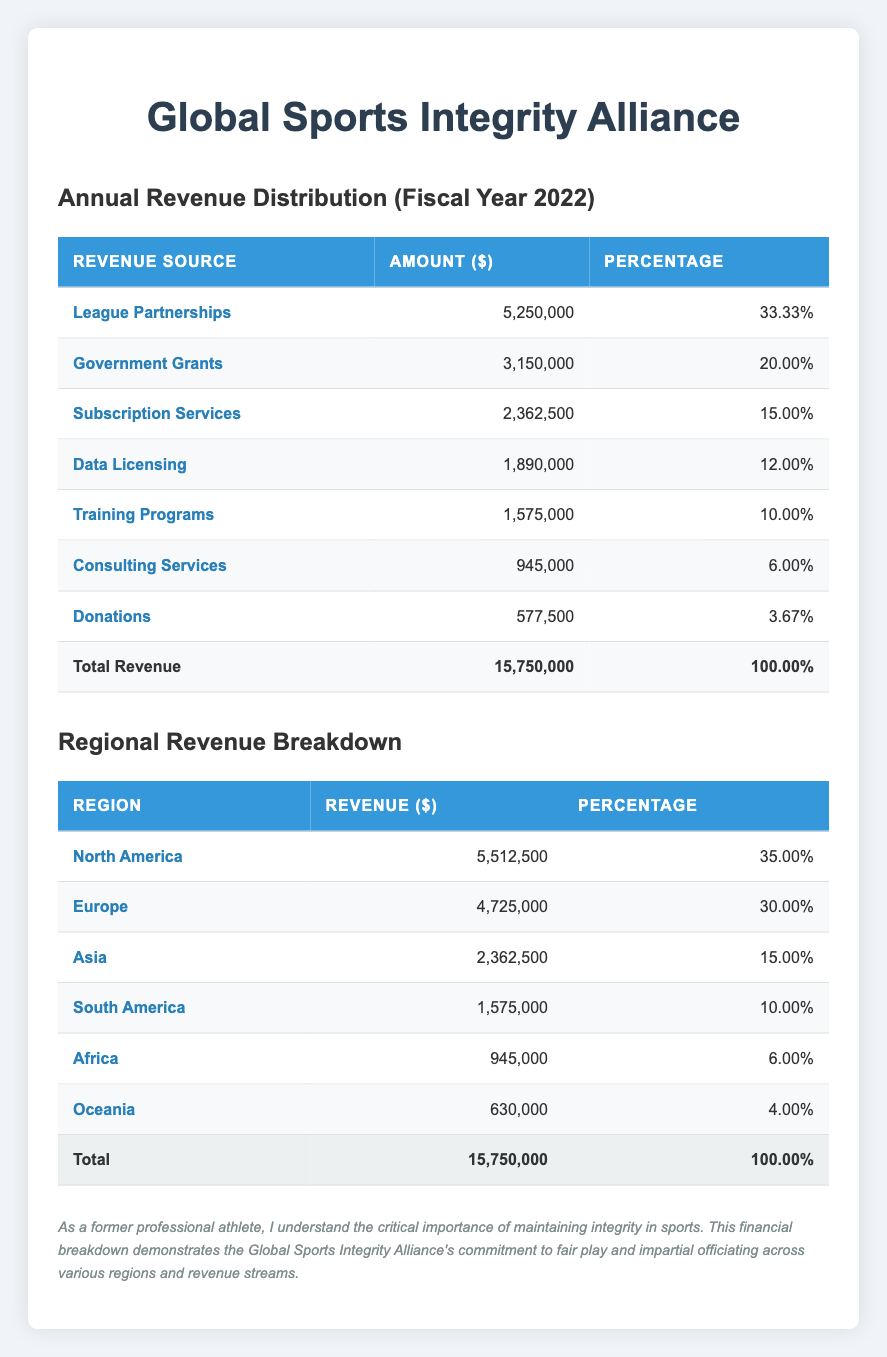What is the total revenue reported for the fiscal year 2022? The total revenue is indicated clearly at the bottom of the first table, which shows "Total Revenue" as 15,750,000.
Answer: 15,750,000 Which revenue source contributed the most to the overall revenue? Looking at the first table, the "League Partnerships" row has the highest amount listed at 5,250,000.
Answer: League Partnerships What percentage of the total revenue comes from Government Grants? From the first table, under the "Government Grants" row, the amount is 3,150,000 and the percentage is listed as 20.00%.
Answer: 20.00% Which region has the lowest revenue contribution? Examining the regional breakdown table, "Oceania" has the lowest revenue at 630,000, as indicated in the corresponding row.
Answer: Oceania If we add up the revenue from North America and Europe, how much total revenue is generated from these two regions? The amount for North America is 5,512,500 and for Europe is 4,725,000. Adding these gives 5,512,500 + 4,725,000 = 10,237,500.
Answer: 10,237,500 Is the revenue from Subscription Services greater than that from Consulting Services? The "Subscription Services" revenue is 2,362,500, while "Consulting Services" revenue is 945,000. Since 2,362,500 > 945,000, the statement is true.
Answer: Yes What is the percentage of total revenue attributed to Data Licensing and Training Programs combined? The "Data Licensing" contributes 12.00% and "Training Programs" contributes 10.00%. Adding these two percentages gives 12.00% + 10.00% = 22.00%.
Answer: 22.00% How much revenue does Asia contribute in comparison to the total revenue? The revenue from Asia is listed as 2,362,500. To understand its proportion, divide this by the total revenue (15,750,000): (2,362,500 / 15,750,000) * 100 = 15.00%.
Answer: 15.00% Are donations a significant source of revenue compared to League Partnerships? Donations amount to 577,500 while League Partnerships contribute 5,250,000. Given that 577,500 is much less than 5,250,000, we can conclude it's not significant.
Answer: No 